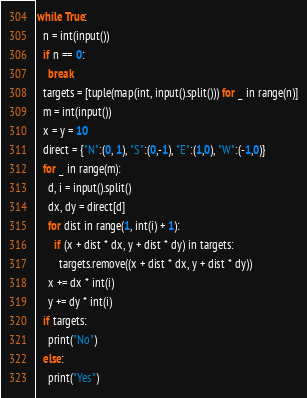<code> <loc_0><loc_0><loc_500><loc_500><_Python_>while True:
  n = int(input())
  if n == 0:
    break
  targets = [tuple(map(int, input().split())) for _ in range(n)]
  m = int(input())
  x = y = 10
  direct = {"N":(0, 1), "S":(0,-1), "E":(1,0), "W":(-1,0)}
  for _ in range(m):
    d, i = input().split()
    dx, dy = direct[d]
    for dist in range(1, int(i) + 1):
      if (x + dist * dx, y + dist * dy) in targets:
        targets.remove((x + dist * dx, y + dist * dy))
    x += dx * int(i)
    y += dy * int(i)
  if targets:
    print("No")
  else:
    print("Yes")

</code> 